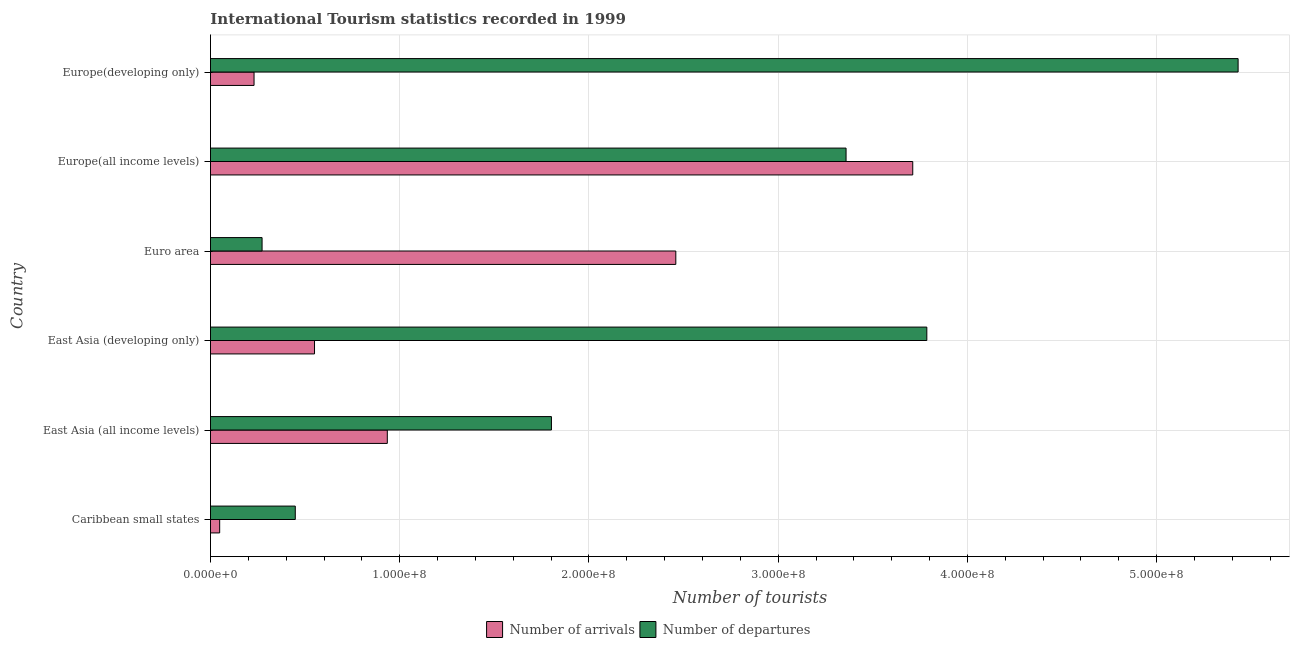How many different coloured bars are there?
Offer a very short reply. 2. Are the number of bars per tick equal to the number of legend labels?
Provide a short and direct response. Yes. Are the number of bars on each tick of the Y-axis equal?
Make the answer very short. Yes. How many bars are there on the 6th tick from the top?
Your response must be concise. 2. What is the label of the 1st group of bars from the top?
Your response must be concise. Europe(developing only). In how many cases, is the number of bars for a given country not equal to the number of legend labels?
Offer a terse response. 0. What is the number of tourist departures in Caribbean small states?
Your answer should be very brief. 4.48e+07. Across all countries, what is the maximum number of tourist departures?
Ensure brevity in your answer.  5.43e+08. Across all countries, what is the minimum number of tourist departures?
Give a very brief answer. 2.73e+07. In which country was the number of tourist arrivals maximum?
Your response must be concise. Europe(all income levels). In which country was the number of tourist arrivals minimum?
Ensure brevity in your answer.  Caribbean small states. What is the total number of tourist arrivals in the graph?
Your answer should be very brief. 7.93e+08. What is the difference between the number of tourist arrivals in East Asia (developing only) and that in Europe(all income levels)?
Offer a very short reply. -3.16e+08. What is the difference between the number of tourist departures in Europe(developing only) and the number of tourist arrivals in East Asia (all income levels)?
Keep it short and to the point. 4.50e+08. What is the average number of tourist arrivals per country?
Your response must be concise. 1.32e+08. What is the difference between the number of tourist departures and number of tourist arrivals in East Asia (all income levels)?
Keep it short and to the point. 8.67e+07. What is the ratio of the number of tourist arrivals in Europe(all income levels) to that in Europe(developing only)?
Give a very brief answer. 16.12. Is the difference between the number of tourist arrivals in East Asia (all income levels) and Europe(developing only) greater than the difference between the number of tourist departures in East Asia (all income levels) and Europe(developing only)?
Give a very brief answer. Yes. What is the difference between the highest and the second highest number of tourist departures?
Your response must be concise. 1.64e+08. What is the difference between the highest and the lowest number of tourist departures?
Offer a terse response. 5.16e+08. In how many countries, is the number of tourist arrivals greater than the average number of tourist arrivals taken over all countries?
Provide a short and direct response. 2. What does the 1st bar from the top in Europe(all income levels) represents?
Your response must be concise. Number of departures. What does the 1st bar from the bottom in Europe(all income levels) represents?
Offer a very short reply. Number of arrivals. How many bars are there?
Offer a terse response. 12. How many countries are there in the graph?
Make the answer very short. 6. Does the graph contain grids?
Give a very brief answer. Yes. How are the legend labels stacked?
Provide a succinct answer. Horizontal. What is the title of the graph?
Give a very brief answer. International Tourism statistics recorded in 1999. Does "Forest land" appear as one of the legend labels in the graph?
Your answer should be very brief. No. What is the label or title of the X-axis?
Provide a succinct answer. Number of tourists. What is the label or title of the Y-axis?
Provide a short and direct response. Country. What is the Number of tourists in Number of arrivals in Caribbean small states?
Keep it short and to the point. 4.86e+06. What is the Number of tourists of Number of departures in Caribbean small states?
Give a very brief answer. 4.48e+07. What is the Number of tourists in Number of arrivals in East Asia (all income levels)?
Your answer should be compact. 9.35e+07. What is the Number of tourists of Number of departures in East Asia (all income levels)?
Provide a short and direct response. 1.80e+08. What is the Number of tourists of Number of arrivals in East Asia (developing only)?
Offer a very short reply. 5.50e+07. What is the Number of tourists in Number of departures in East Asia (developing only)?
Ensure brevity in your answer.  3.79e+08. What is the Number of tourists of Number of arrivals in Euro area?
Provide a succinct answer. 2.46e+08. What is the Number of tourists of Number of departures in Euro area?
Provide a succinct answer. 2.73e+07. What is the Number of tourists in Number of arrivals in Europe(all income levels)?
Keep it short and to the point. 3.71e+08. What is the Number of tourists in Number of departures in Europe(all income levels)?
Give a very brief answer. 3.36e+08. What is the Number of tourists of Number of arrivals in Europe(developing only)?
Offer a terse response. 2.30e+07. What is the Number of tourists of Number of departures in Europe(developing only)?
Your response must be concise. 5.43e+08. Across all countries, what is the maximum Number of tourists in Number of arrivals?
Offer a terse response. 3.71e+08. Across all countries, what is the maximum Number of tourists of Number of departures?
Your answer should be very brief. 5.43e+08. Across all countries, what is the minimum Number of tourists of Number of arrivals?
Give a very brief answer. 4.86e+06. Across all countries, what is the minimum Number of tourists of Number of departures?
Offer a terse response. 2.73e+07. What is the total Number of tourists in Number of arrivals in the graph?
Make the answer very short. 7.93e+08. What is the total Number of tourists in Number of departures in the graph?
Ensure brevity in your answer.  1.51e+09. What is the difference between the Number of tourists of Number of arrivals in Caribbean small states and that in East Asia (all income levels)?
Ensure brevity in your answer.  -8.86e+07. What is the difference between the Number of tourists of Number of departures in Caribbean small states and that in East Asia (all income levels)?
Provide a short and direct response. -1.35e+08. What is the difference between the Number of tourists in Number of arrivals in Caribbean small states and that in East Asia (developing only)?
Keep it short and to the point. -5.01e+07. What is the difference between the Number of tourists in Number of departures in Caribbean small states and that in East Asia (developing only)?
Give a very brief answer. -3.34e+08. What is the difference between the Number of tourists in Number of arrivals in Caribbean small states and that in Euro area?
Provide a short and direct response. -2.41e+08. What is the difference between the Number of tourists of Number of departures in Caribbean small states and that in Euro area?
Offer a very short reply. 1.76e+07. What is the difference between the Number of tourists of Number of arrivals in Caribbean small states and that in Europe(all income levels)?
Offer a very short reply. -3.66e+08. What is the difference between the Number of tourists in Number of departures in Caribbean small states and that in Europe(all income levels)?
Provide a short and direct response. -2.91e+08. What is the difference between the Number of tourists of Number of arrivals in Caribbean small states and that in Europe(developing only)?
Offer a terse response. -1.82e+07. What is the difference between the Number of tourists in Number of departures in Caribbean small states and that in Europe(developing only)?
Provide a short and direct response. -4.98e+08. What is the difference between the Number of tourists of Number of arrivals in East Asia (all income levels) and that in East Asia (developing only)?
Provide a short and direct response. 3.85e+07. What is the difference between the Number of tourists of Number of departures in East Asia (all income levels) and that in East Asia (developing only)?
Offer a very short reply. -1.98e+08. What is the difference between the Number of tourists in Number of arrivals in East Asia (all income levels) and that in Euro area?
Ensure brevity in your answer.  -1.52e+08. What is the difference between the Number of tourists in Number of departures in East Asia (all income levels) and that in Euro area?
Make the answer very short. 1.53e+08. What is the difference between the Number of tourists of Number of arrivals in East Asia (all income levels) and that in Europe(all income levels)?
Offer a very short reply. -2.78e+08. What is the difference between the Number of tourists of Number of departures in East Asia (all income levels) and that in Europe(all income levels)?
Ensure brevity in your answer.  -1.56e+08. What is the difference between the Number of tourists of Number of arrivals in East Asia (all income levels) and that in Europe(developing only)?
Provide a short and direct response. 7.04e+07. What is the difference between the Number of tourists in Number of departures in East Asia (all income levels) and that in Europe(developing only)?
Give a very brief answer. -3.63e+08. What is the difference between the Number of tourists of Number of arrivals in East Asia (developing only) and that in Euro area?
Your answer should be very brief. -1.91e+08. What is the difference between the Number of tourists in Number of departures in East Asia (developing only) and that in Euro area?
Your answer should be very brief. 3.51e+08. What is the difference between the Number of tourists in Number of arrivals in East Asia (developing only) and that in Europe(all income levels)?
Your answer should be compact. -3.16e+08. What is the difference between the Number of tourists in Number of departures in East Asia (developing only) and that in Europe(all income levels)?
Offer a very short reply. 4.27e+07. What is the difference between the Number of tourists of Number of arrivals in East Asia (developing only) and that in Europe(developing only)?
Give a very brief answer. 3.20e+07. What is the difference between the Number of tourists in Number of departures in East Asia (developing only) and that in Europe(developing only)?
Give a very brief answer. -1.64e+08. What is the difference between the Number of tourists of Number of arrivals in Euro area and that in Europe(all income levels)?
Give a very brief answer. -1.25e+08. What is the difference between the Number of tourists of Number of departures in Euro area and that in Europe(all income levels)?
Make the answer very short. -3.09e+08. What is the difference between the Number of tourists in Number of arrivals in Euro area and that in Europe(developing only)?
Your answer should be very brief. 2.23e+08. What is the difference between the Number of tourists of Number of departures in Euro area and that in Europe(developing only)?
Your response must be concise. -5.16e+08. What is the difference between the Number of tourists of Number of arrivals in Europe(all income levels) and that in Europe(developing only)?
Keep it short and to the point. 3.48e+08. What is the difference between the Number of tourists in Number of departures in Europe(all income levels) and that in Europe(developing only)?
Your answer should be very brief. -2.07e+08. What is the difference between the Number of tourists in Number of arrivals in Caribbean small states and the Number of tourists in Number of departures in East Asia (all income levels)?
Provide a succinct answer. -1.75e+08. What is the difference between the Number of tourists of Number of arrivals in Caribbean small states and the Number of tourists of Number of departures in East Asia (developing only)?
Keep it short and to the point. -3.74e+08. What is the difference between the Number of tourists of Number of arrivals in Caribbean small states and the Number of tourists of Number of departures in Euro area?
Provide a succinct answer. -2.24e+07. What is the difference between the Number of tourists in Number of arrivals in Caribbean small states and the Number of tourists in Number of departures in Europe(all income levels)?
Offer a terse response. -3.31e+08. What is the difference between the Number of tourists in Number of arrivals in Caribbean small states and the Number of tourists in Number of departures in Europe(developing only)?
Offer a terse response. -5.38e+08. What is the difference between the Number of tourists in Number of arrivals in East Asia (all income levels) and the Number of tourists in Number of departures in East Asia (developing only)?
Provide a succinct answer. -2.85e+08. What is the difference between the Number of tourists of Number of arrivals in East Asia (all income levels) and the Number of tourists of Number of departures in Euro area?
Your response must be concise. 6.62e+07. What is the difference between the Number of tourists in Number of arrivals in East Asia (all income levels) and the Number of tourists in Number of departures in Europe(all income levels)?
Provide a succinct answer. -2.42e+08. What is the difference between the Number of tourists of Number of arrivals in East Asia (all income levels) and the Number of tourists of Number of departures in Europe(developing only)?
Provide a succinct answer. -4.50e+08. What is the difference between the Number of tourists of Number of arrivals in East Asia (developing only) and the Number of tourists of Number of departures in Euro area?
Provide a succinct answer. 2.77e+07. What is the difference between the Number of tourists of Number of arrivals in East Asia (developing only) and the Number of tourists of Number of departures in Europe(all income levels)?
Your response must be concise. -2.81e+08. What is the difference between the Number of tourists of Number of arrivals in East Asia (developing only) and the Number of tourists of Number of departures in Europe(developing only)?
Your response must be concise. -4.88e+08. What is the difference between the Number of tourists of Number of arrivals in Euro area and the Number of tourists of Number of departures in Europe(all income levels)?
Offer a terse response. -9.00e+07. What is the difference between the Number of tourists in Number of arrivals in Euro area and the Number of tourists in Number of departures in Europe(developing only)?
Offer a terse response. -2.97e+08. What is the difference between the Number of tourists of Number of arrivals in Europe(all income levels) and the Number of tourists of Number of departures in Europe(developing only)?
Your answer should be compact. -1.72e+08. What is the average Number of tourists in Number of arrivals per country?
Make the answer very short. 1.32e+08. What is the average Number of tourists of Number of departures per country?
Provide a succinct answer. 2.52e+08. What is the difference between the Number of tourists of Number of arrivals and Number of tourists of Number of departures in Caribbean small states?
Keep it short and to the point. -4.00e+07. What is the difference between the Number of tourists in Number of arrivals and Number of tourists in Number of departures in East Asia (all income levels)?
Provide a succinct answer. -8.67e+07. What is the difference between the Number of tourists of Number of arrivals and Number of tourists of Number of departures in East Asia (developing only)?
Offer a very short reply. -3.24e+08. What is the difference between the Number of tourists in Number of arrivals and Number of tourists in Number of departures in Euro area?
Ensure brevity in your answer.  2.19e+08. What is the difference between the Number of tourists of Number of arrivals and Number of tourists of Number of departures in Europe(all income levels)?
Offer a terse response. 3.52e+07. What is the difference between the Number of tourists of Number of arrivals and Number of tourists of Number of departures in Europe(developing only)?
Offer a very short reply. -5.20e+08. What is the ratio of the Number of tourists in Number of arrivals in Caribbean small states to that in East Asia (all income levels)?
Your response must be concise. 0.05. What is the ratio of the Number of tourists in Number of departures in Caribbean small states to that in East Asia (all income levels)?
Offer a terse response. 0.25. What is the ratio of the Number of tourists in Number of arrivals in Caribbean small states to that in East Asia (developing only)?
Ensure brevity in your answer.  0.09. What is the ratio of the Number of tourists in Number of departures in Caribbean small states to that in East Asia (developing only)?
Provide a succinct answer. 0.12. What is the ratio of the Number of tourists of Number of arrivals in Caribbean small states to that in Euro area?
Ensure brevity in your answer.  0.02. What is the ratio of the Number of tourists of Number of departures in Caribbean small states to that in Euro area?
Give a very brief answer. 1.64. What is the ratio of the Number of tourists of Number of arrivals in Caribbean small states to that in Europe(all income levels)?
Offer a very short reply. 0.01. What is the ratio of the Number of tourists in Number of departures in Caribbean small states to that in Europe(all income levels)?
Give a very brief answer. 0.13. What is the ratio of the Number of tourists in Number of arrivals in Caribbean small states to that in Europe(developing only)?
Provide a short and direct response. 0.21. What is the ratio of the Number of tourists of Number of departures in Caribbean small states to that in Europe(developing only)?
Provide a succinct answer. 0.08. What is the ratio of the Number of tourists of Number of arrivals in East Asia (all income levels) to that in East Asia (developing only)?
Ensure brevity in your answer.  1.7. What is the ratio of the Number of tourists of Number of departures in East Asia (all income levels) to that in East Asia (developing only)?
Your response must be concise. 0.48. What is the ratio of the Number of tourists of Number of arrivals in East Asia (all income levels) to that in Euro area?
Your response must be concise. 0.38. What is the ratio of the Number of tourists of Number of departures in East Asia (all income levels) to that in Euro area?
Your answer should be compact. 6.61. What is the ratio of the Number of tourists of Number of arrivals in East Asia (all income levels) to that in Europe(all income levels)?
Keep it short and to the point. 0.25. What is the ratio of the Number of tourists in Number of departures in East Asia (all income levels) to that in Europe(all income levels)?
Give a very brief answer. 0.54. What is the ratio of the Number of tourists of Number of arrivals in East Asia (all income levels) to that in Europe(developing only)?
Give a very brief answer. 4.06. What is the ratio of the Number of tourists of Number of departures in East Asia (all income levels) to that in Europe(developing only)?
Make the answer very short. 0.33. What is the ratio of the Number of tourists in Number of arrivals in East Asia (developing only) to that in Euro area?
Offer a terse response. 0.22. What is the ratio of the Number of tourists of Number of departures in East Asia (developing only) to that in Euro area?
Your answer should be compact. 13.88. What is the ratio of the Number of tourists of Number of arrivals in East Asia (developing only) to that in Europe(all income levels)?
Provide a succinct answer. 0.15. What is the ratio of the Number of tourists of Number of departures in East Asia (developing only) to that in Europe(all income levels)?
Offer a very short reply. 1.13. What is the ratio of the Number of tourists in Number of arrivals in East Asia (developing only) to that in Europe(developing only)?
Offer a terse response. 2.39. What is the ratio of the Number of tourists of Number of departures in East Asia (developing only) to that in Europe(developing only)?
Give a very brief answer. 0.7. What is the ratio of the Number of tourists of Number of arrivals in Euro area to that in Europe(all income levels)?
Ensure brevity in your answer.  0.66. What is the ratio of the Number of tourists in Number of departures in Euro area to that in Europe(all income levels)?
Your response must be concise. 0.08. What is the ratio of the Number of tourists of Number of arrivals in Euro area to that in Europe(developing only)?
Ensure brevity in your answer.  10.68. What is the ratio of the Number of tourists of Number of departures in Euro area to that in Europe(developing only)?
Provide a short and direct response. 0.05. What is the ratio of the Number of tourists in Number of arrivals in Europe(all income levels) to that in Europe(developing only)?
Keep it short and to the point. 16.12. What is the ratio of the Number of tourists in Number of departures in Europe(all income levels) to that in Europe(developing only)?
Your answer should be compact. 0.62. What is the difference between the highest and the second highest Number of tourists of Number of arrivals?
Provide a short and direct response. 1.25e+08. What is the difference between the highest and the second highest Number of tourists in Number of departures?
Ensure brevity in your answer.  1.64e+08. What is the difference between the highest and the lowest Number of tourists of Number of arrivals?
Your response must be concise. 3.66e+08. What is the difference between the highest and the lowest Number of tourists of Number of departures?
Keep it short and to the point. 5.16e+08. 